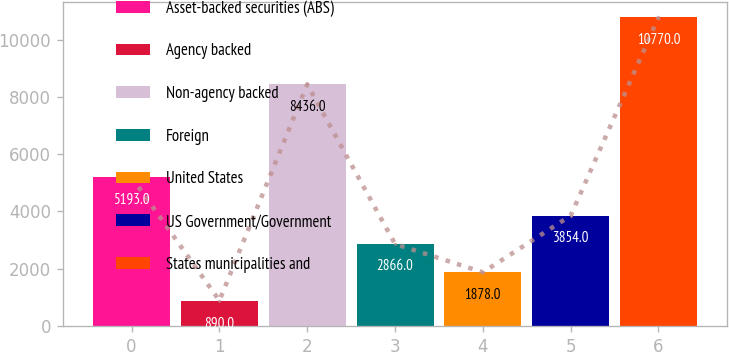Convert chart. <chart><loc_0><loc_0><loc_500><loc_500><bar_chart><fcel>Asset-backed securities (ABS)<fcel>Agency backed<fcel>Non-agency backed<fcel>Foreign<fcel>United States<fcel>US Government/Government<fcel>States municipalities and<nl><fcel>5193<fcel>890<fcel>8436<fcel>2866<fcel>1878<fcel>3854<fcel>10770<nl></chart> 